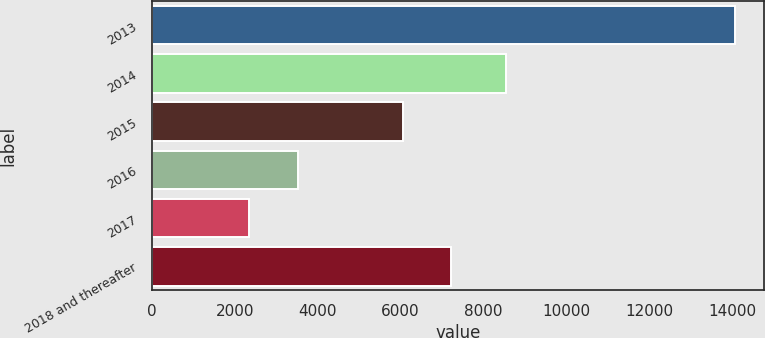<chart> <loc_0><loc_0><loc_500><loc_500><bar_chart><fcel>2013<fcel>2014<fcel>2015<fcel>2016<fcel>2017<fcel>2018 and thereafter<nl><fcel>14078<fcel>8543<fcel>6048<fcel>3520.1<fcel>2347<fcel>7221.1<nl></chart> 